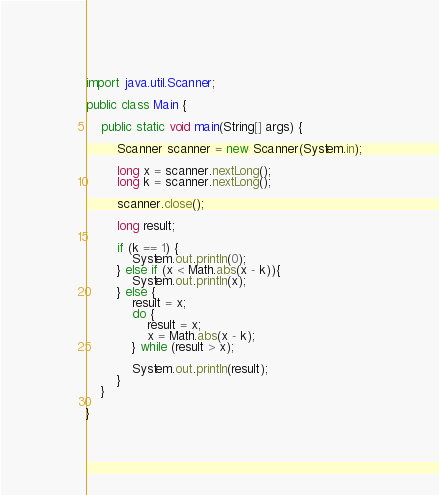Convert code to text. <code><loc_0><loc_0><loc_500><loc_500><_Java_>import java.util.Scanner;

public class Main {
	
	public static void main(String[] args) {
		
		Scanner scanner = new Scanner(System.in);
		
		long x = scanner.nextLong();
		long k = scanner.nextLong();
		
		scanner.close();
		
		long result;
		
		if (k == 1) {
			System.out.println(0);
		} else if (x < Math.abs(x - k)){
			System.out.println(x);
		} else {
			result = x;
			do {
				result = x;
				x = Math.abs(x - k);
			} while (result > x);
			
			System.out.println(result);
		}
	}

}
</code> 